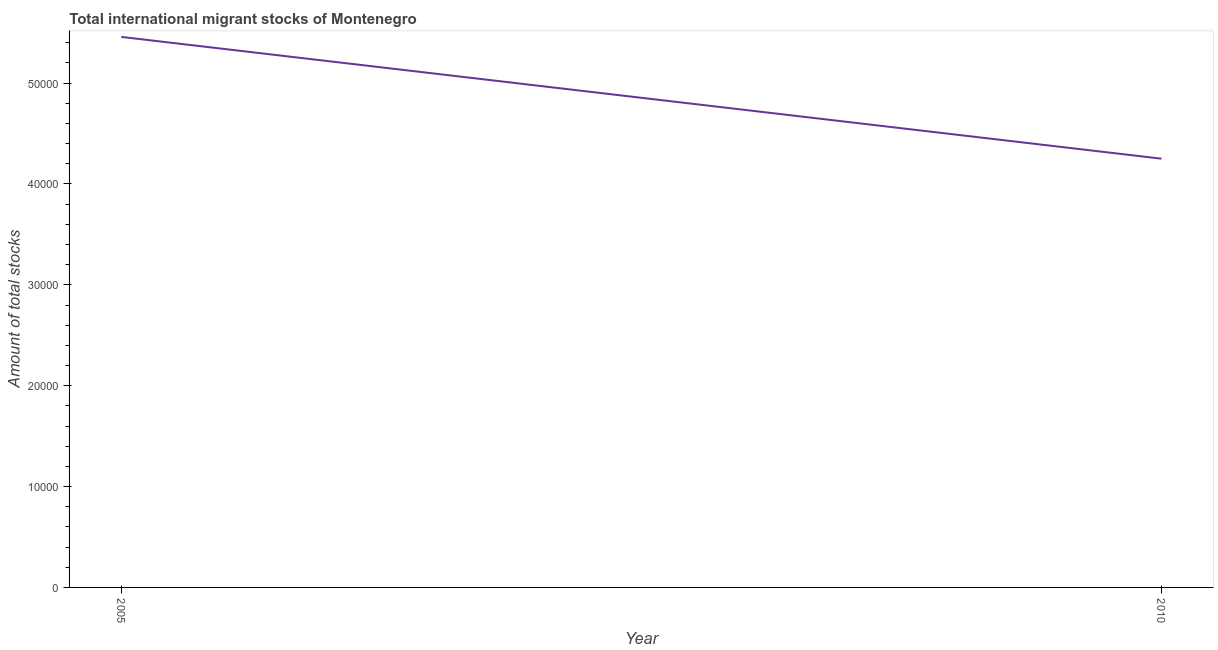What is the total number of international migrant stock in 2010?
Give a very brief answer. 4.25e+04. Across all years, what is the maximum total number of international migrant stock?
Provide a succinct answer. 5.46e+04. Across all years, what is the minimum total number of international migrant stock?
Ensure brevity in your answer.  4.25e+04. What is the sum of the total number of international migrant stock?
Your answer should be very brief. 9.71e+04. What is the difference between the total number of international migrant stock in 2005 and 2010?
Your response must be concise. 1.21e+04. What is the average total number of international migrant stock per year?
Keep it short and to the point. 4.85e+04. What is the median total number of international migrant stock?
Offer a terse response. 4.85e+04. What is the ratio of the total number of international migrant stock in 2005 to that in 2010?
Your response must be concise. 1.28. In how many years, is the total number of international migrant stock greater than the average total number of international migrant stock taken over all years?
Provide a succinct answer. 1. Does the total number of international migrant stock monotonically increase over the years?
Your response must be concise. No. How many lines are there?
Your response must be concise. 1. Are the values on the major ticks of Y-axis written in scientific E-notation?
Make the answer very short. No. Does the graph contain any zero values?
Ensure brevity in your answer.  No. Does the graph contain grids?
Offer a terse response. No. What is the title of the graph?
Offer a terse response. Total international migrant stocks of Montenegro. What is the label or title of the X-axis?
Make the answer very short. Year. What is the label or title of the Y-axis?
Give a very brief answer. Amount of total stocks. What is the Amount of total stocks of 2005?
Keep it short and to the point. 5.46e+04. What is the Amount of total stocks in 2010?
Your answer should be compact. 4.25e+04. What is the difference between the Amount of total stocks in 2005 and 2010?
Your answer should be very brief. 1.21e+04. What is the ratio of the Amount of total stocks in 2005 to that in 2010?
Keep it short and to the point. 1.28. 